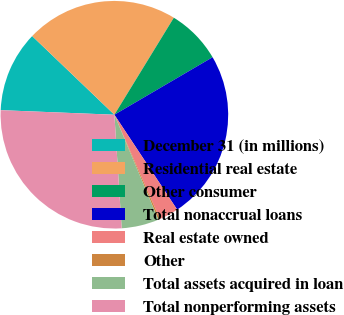Convert chart to OTSL. <chart><loc_0><loc_0><loc_500><loc_500><pie_chart><fcel>December 31 (in millions)<fcel>Residential real estate<fcel>Other consumer<fcel>Total nonaccrual loans<fcel>Real estate owned<fcel>Other<fcel>Total assets acquired in loan<fcel>Total nonperforming assets<nl><fcel>11.51%<fcel>21.6%<fcel>7.82%<fcel>24.13%<fcel>2.76%<fcel>0.23%<fcel>5.29%<fcel>26.66%<nl></chart> 